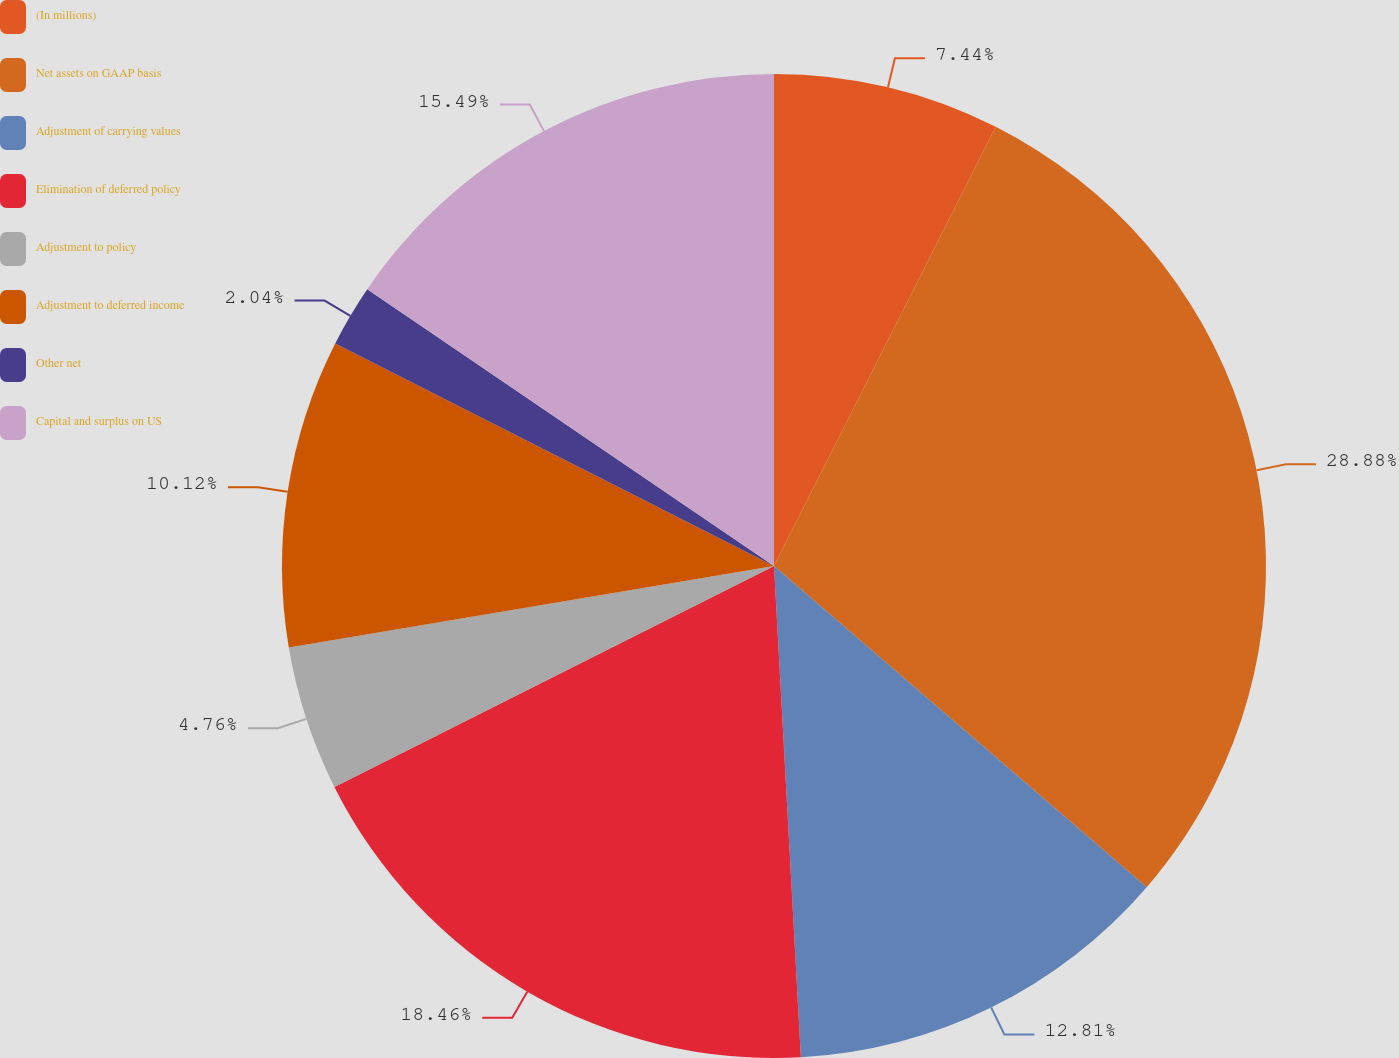Convert chart to OTSL. <chart><loc_0><loc_0><loc_500><loc_500><pie_chart><fcel>(In millions)<fcel>Net assets on GAAP basis<fcel>Adjustment of carrying values<fcel>Elimination of deferred policy<fcel>Adjustment to policy<fcel>Adjustment to deferred income<fcel>Other net<fcel>Capital and surplus on US<nl><fcel>7.44%<fcel>28.88%<fcel>12.81%<fcel>18.46%<fcel>4.76%<fcel>10.12%<fcel>2.04%<fcel>15.49%<nl></chart> 